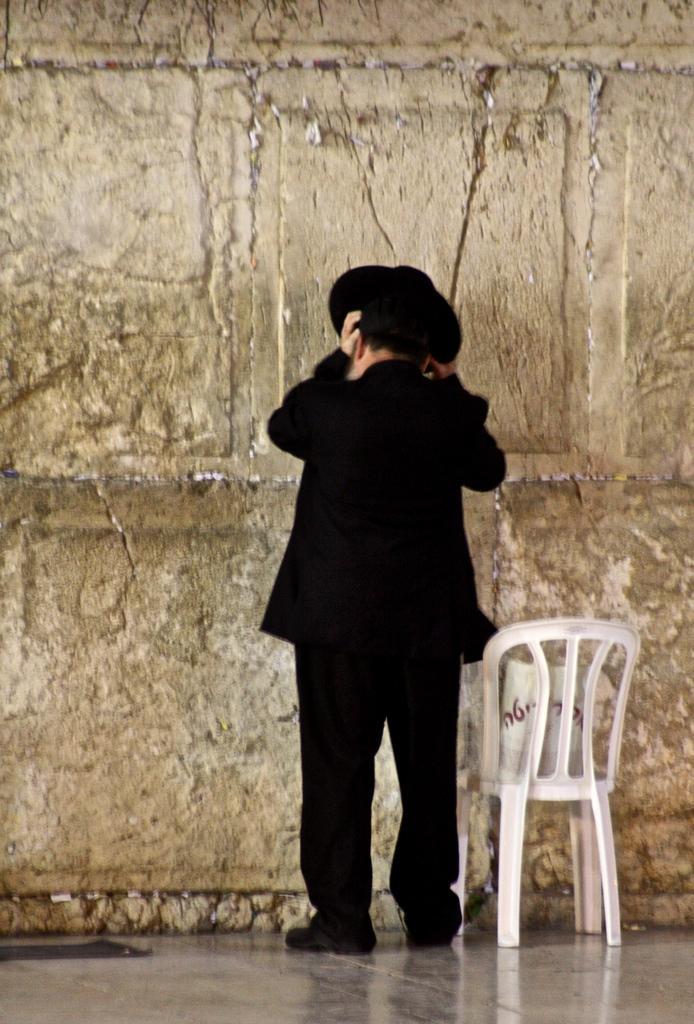In one or two sentences, can you explain what this image depicts? In the image there is a man stood in the middle wearing black dress,black hat. beside him there is a chair,in front of him there is a wall. 